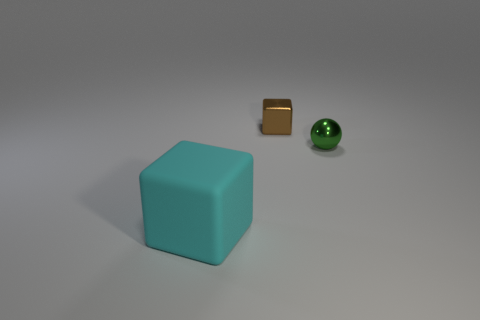Are there any other things that are made of the same material as the cyan object?
Ensure brevity in your answer.  No. What is the shape of the object in front of the tiny object in front of the brown shiny object?
Your response must be concise. Cube. How many objects are big blue metal cylinders or small objects right of the tiny brown shiny thing?
Provide a short and direct response. 1. How many brown things are either matte cubes or metallic cubes?
Keep it short and to the point. 1. There is a tiny metallic object that is to the right of the cube that is behind the cyan rubber thing; are there any brown objects that are right of it?
Provide a succinct answer. No. Is there anything else that is the same size as the cyan block?
Give a very brief answer. No. Does the rubber object have the same color as the small metallic sphere?
Your answer should be very brief. No. The cube that is to the right of the block that is in front of the tiny brown metal block is what color?
Your answer should be compact. Brown. How many big objects are red shiny objects or rubber things?
Your answer should be compact. 1. There is a object that is in front of the shiny cube and to the left of the tiny green metal thing; what color is it?
Offer a terse response. Cyan. 